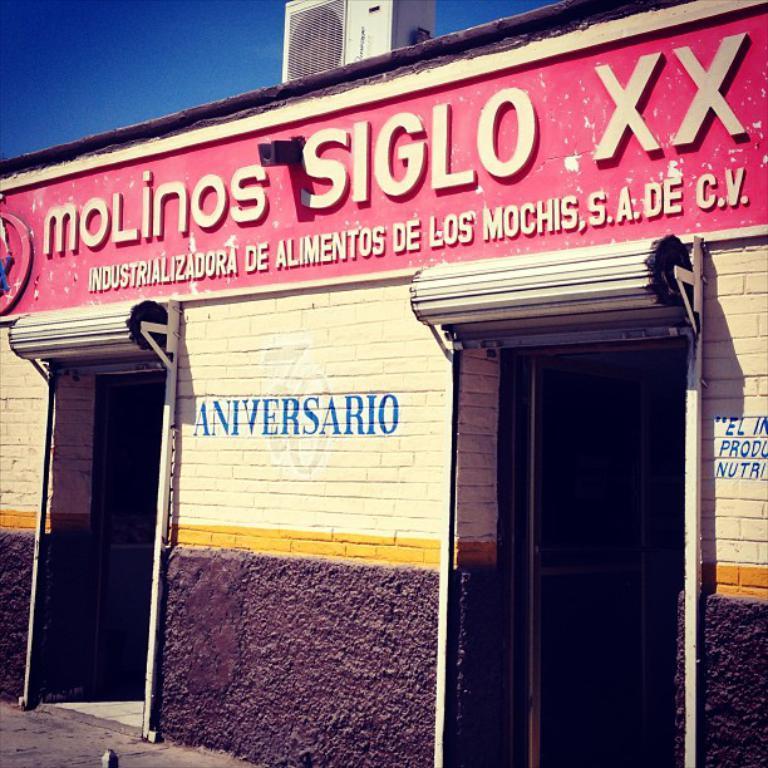Can you describe this image briefly? In this picture, we see a building in white and black color. We see some text written on the wall. On the right side, we see the door. On top of the building, we see a board in pink color with some text written on it. At the top, we see the grid air conditioner. In the left top, we see the sky, which is blue in color. In the left bottom, we see the road. 